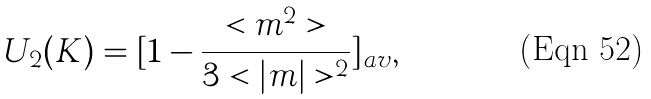Convert formula to latex. <formula><loc_0><loc_0><loc_500><loc_500>U _ { 2 } ( K ) = [ 1 - \frac { < m ^ { 2 } > } { 3 < | m | > ^ { 2 } } ] _ { a v } ,</formula> 